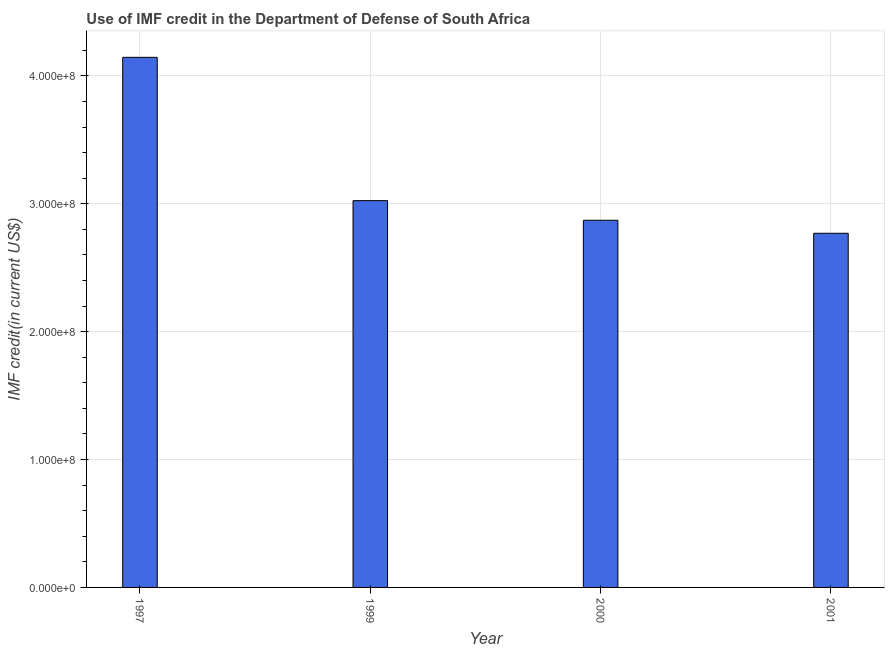Does the graph contain any zero values?
Keep it short and to the point. No. Does the graph contain grids?
Your response must be concise. Yes. What is the title of the graph?
Provide a succinct answer. Use of IMF credit in the Department of Defense of South Africa. What is the label or title of the X-axis?
Provide a short and direct response. Year. What is the label or title of the Y-axis?
Make the answer very short. IMF credit(in current US$). What is the use of imf credit in dod in 1997?
Keep it short and to the point. 4.15e+08. Across all years, what is the maximum use of imf credit in dod?
Keep it short and to the point. 4.15e+08. Across all years, what is the minimum use of imf credit in dod?
Offer a very short reply. 2.77e+08. In which year was the use of imf credit in dod maximum?
Provide a succinct answer. 1997. In which year was the use of imf credit in dod minimum?
Offer a very short reply. 2001. What is the sum of the use of imf credit in dod?
Offer a terse response. 1.28e+09. What is the difference between the use of imf credit in dod in 1999 and 2000?
Ensure brevity in your answer.  1.53e+07. What is the average use of imf credit in dod per year?
Keep it short and to the point. 3.20e+08. What is the median use of imf credit in dod?
Keep it short and to the point. 2.95e+08. Do a majority of the years between 1999 and 2000 (inclusive) have use of imf credit in dod greater than 320000000 US$?
Offer a terse response. No. What is the ratio of the use of imf credit in dod in 1999 to that in 2001?
Provide a succinct answer. 1.09. Is the difference between the use of imf credit in dod in 2000 and 2001 greater than the difference between any two years?
Your answer should be very brief. No. What is the difference between the highest and the second highest use of imf credit in dod?
Keep it short and to the point. 1.12e+08. What is the difference between the highest and the lowest use of imf credit in dod?
Your answer should be very brief. 1.38e+08. What is the IMF credit(in current US$) in 1997?
Give a very brief answer. 4.15e+08. What is the IMF credit(in current US$) of 1999?
Offer a terse response. 3.02e+08. What is the IMF credit(in current US$) in 2000?
Offer a terse response. 2.87e+08. What is the IMF credit(in current US$) of 2001?
Your answer should be very brief. 2.77e+08. What is the difference between the IMF credit(in current US$) in 1997 and 1999?
Provide a short and direct response. 1.12e+08. What is the difference between the IMF credit(in current US$) in 1997 and 2000?
Keep it short and to the point. 1.27e+08. What is the difference between the IMF credit(in current US$) in 1997 and 2001?
Offer a terse response. 1.38e+08. What is the difference between the IMF credit(in current US$) in 1999 and 2000?
Make the answer very short. 1.53e+07. What is the difference between the IMF credit(in current US$) in 1999 and 2001?
Make the answer very short. 2.55e+07. What is the difference between the IMF credit(in current US$) in 2000 and 2001?
Your response must be concise. 1.02e+07. What is the ratio of the IMF credit(in current US$) in 1997 to that in 1999?
Your answer should be compact. 1.37. What is the ratio of the IMF credit(in current US$) in 1997 to that in 2000?
Provide a short and direct response. 1.44. What is the ratio of the IMF credit(in current US$) in 1997 to that in 2001?
Ensure brevity in your answer.  1.5. What is the ratio of the IMF credit(in current US$) in 1999 to that in 2000?
Give a very brief answer. 1.05. What is the ratio of the IMF credit(in current US$) in 1999 to that in 2001?
Provide a short and direct response. 1.09. What is the ratio of the IMF credit(in current US$) in 2000 to that in 2001?
Your response must be concise. 1.04. 